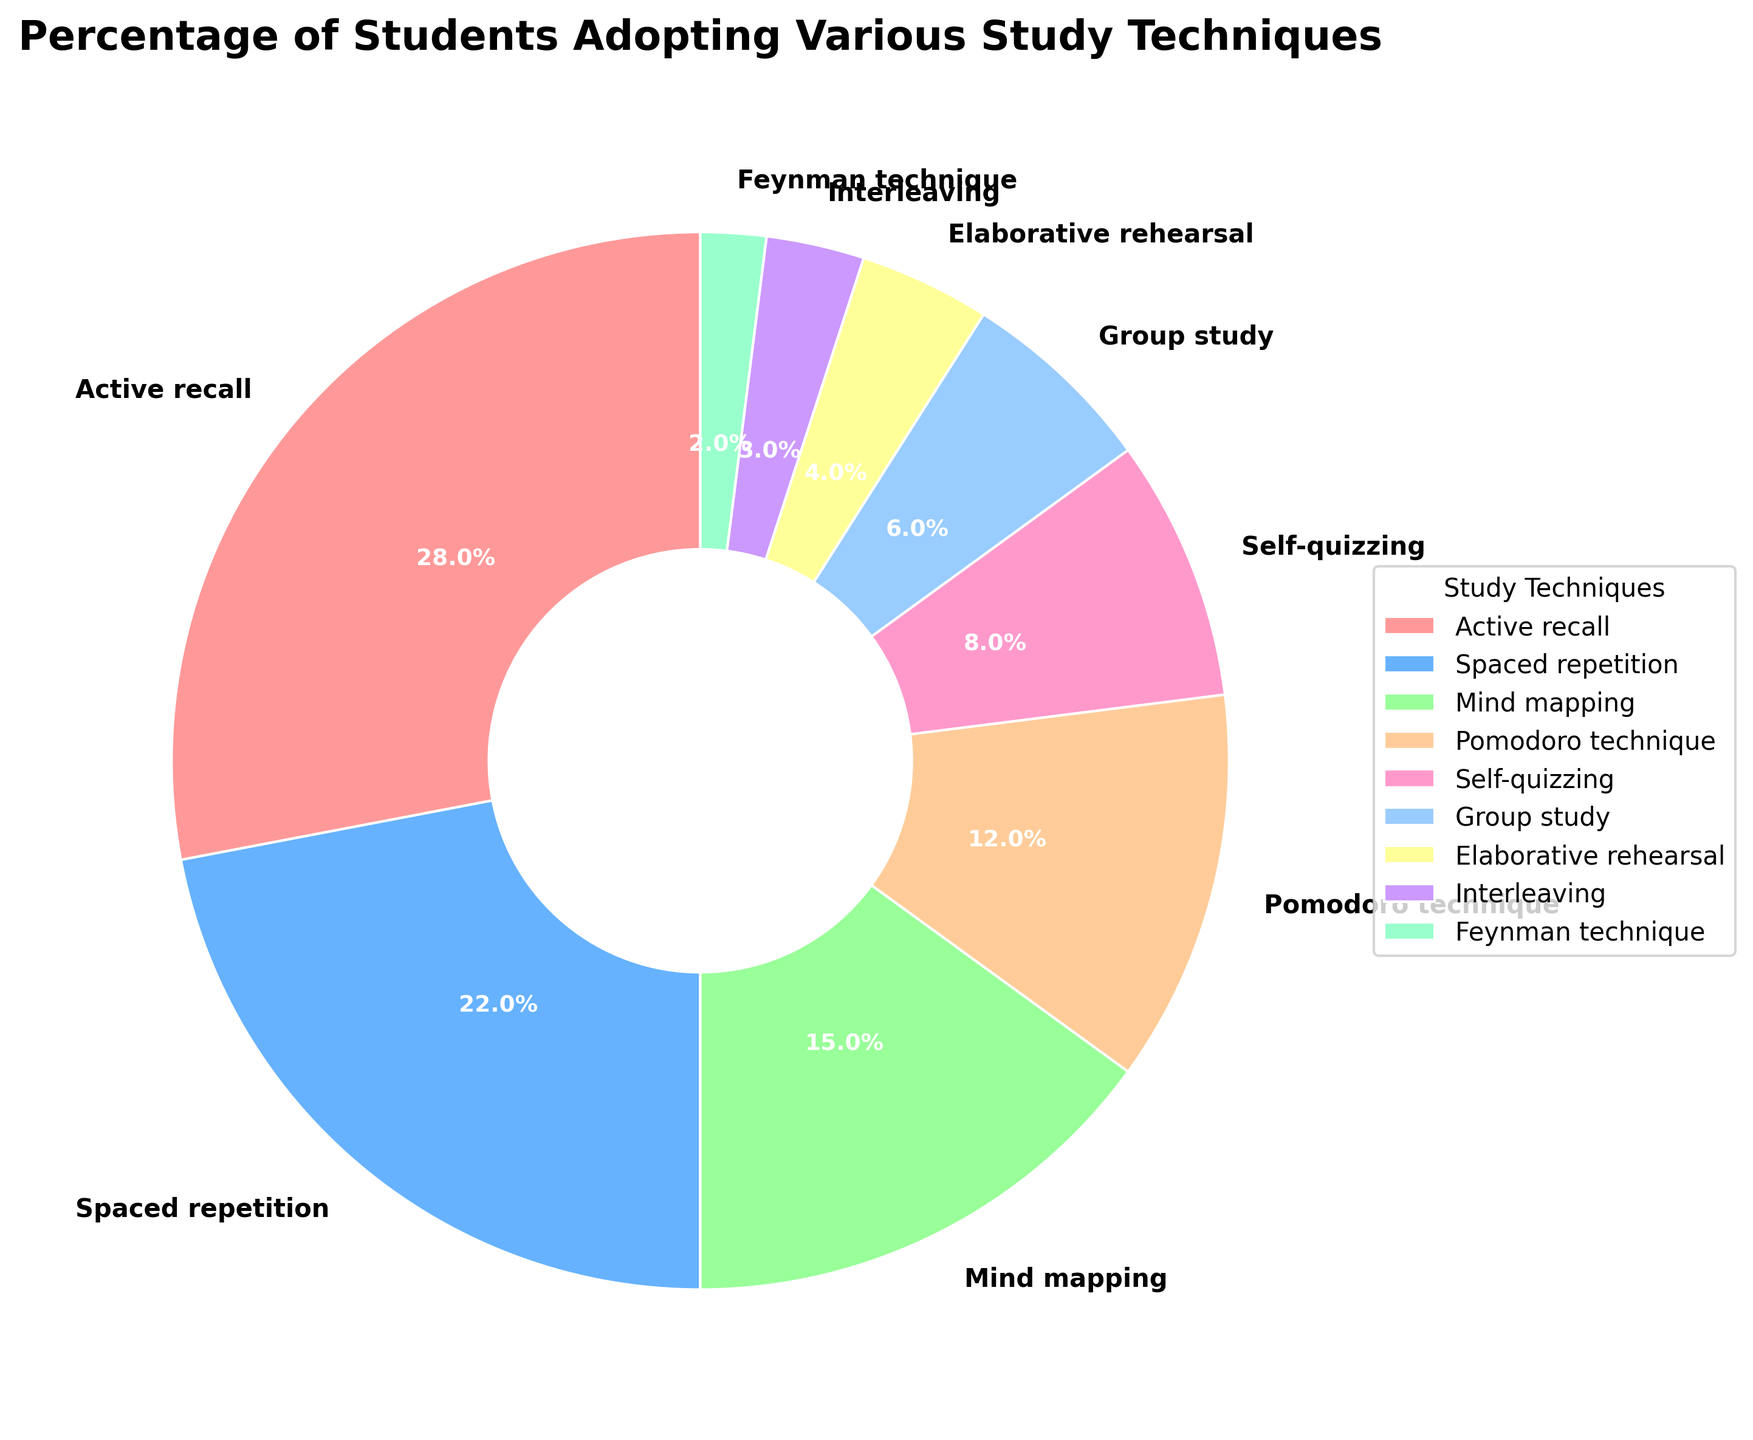Which study technique is adopted by the highest percentage of students? The figure shows various study techniques along with their respective percentages. The study technique with the largest slice in the pie chart represents the highest percentage of students adopting that technique. From the figure, "Active recall" has the largest slice.
Answer: Active recall What is the combined percentage of students using Spaced Repetition, Mind Mapping, and Pomodoro Technique? To find the combined percentage, add the percentages of Spaced Repetition (22%), Mind Mapping (15%), and Pomodoro Technique (12%). 22 + 15 + 12 = 49.
Answer: 49 How does the adoption rate of Group Study compare to that of Self-Quizzing? The figure shows the percentages for both Group Study and Self-Quizzing. The percentage for Group Study is 6%, while the percentage for Self-Quizzing is 8%. So, Group Study is adopted by 2% fewer students than Self-Quizzing.
Answer: Self-Quizzing is 2% higher What percentage of students use techniques that fall under 10% adoption rate each? To find this, sum the percentages of all techniques that have under 10% each: Self-Quizzing (8%), Group Study (6%), Elaborative Rehearsal (4%), Interleaving (3%), and Feynman Technique (2%). 8 + 6 + 4 + 3 + 2 = 23.
Answer: 23 What is the difference in adoption rates between the most and least popular techniques? Identify the most popular technique (Active recall at 28%) and the least popular technique (Feynman Technique at 2%). Calculate the difference: 28 - 2 = 26.
Answer: 26 What color represents the Pomodoro Technique on the pie chart? The pie chart uses specific colors for each technique. The Pomodoro Technique is represented by the slice with a light brownish color. By examining the legend, this color corresponds to the Pomodoro Technique.
Answer: light brownish What is the average adoption rate of all the techniques combined? To find the average, add all the percentages and divide by the number of techniques: (28 + 22 + 15 + 12 + 8 + 6 + 4 + 3 + 2) / 9. The total is 100, and dividing by 9 gives approximately 11.11.
Answer: 11.11 